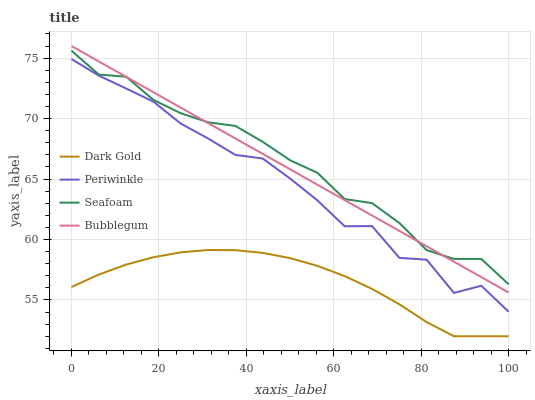Does Dark Gold have the minimum area under the curve?
Answer yes or no. Yes. Does Seafoam have the maximum area under the curve?
Answer yes or no. Yes. Does Bubblegum have the minimum area under the curve?
Answer yes or no. No. Does Bubblegum have the maximum area under the curve?
Answer yes or no. No. Is Bubblegum the smoothest?
Answer yes or no. Yes. Is Periwinkle the roughest?
Answer yes or no. Yes. Is Seafoam the smoothest?
Answer yes or no. No. Is Seafoam the roughest?
Answer yes or no. No. Does Bubblegum have the lowest value?
Answer yes or no. No. Does Bubblegum have the highest value?
Answer yes or no. Yes. Does Seafoam have the highest value?
Answer yes or no. No. Is Dark Gold less than Bubblegum?
Answer yes or no. Yes. Is Bubblegum greater than Periwinkle?
Answer yes or no. Yes. Does Dark Gold intersect Bubblegum?
Answer yes or no. No. 